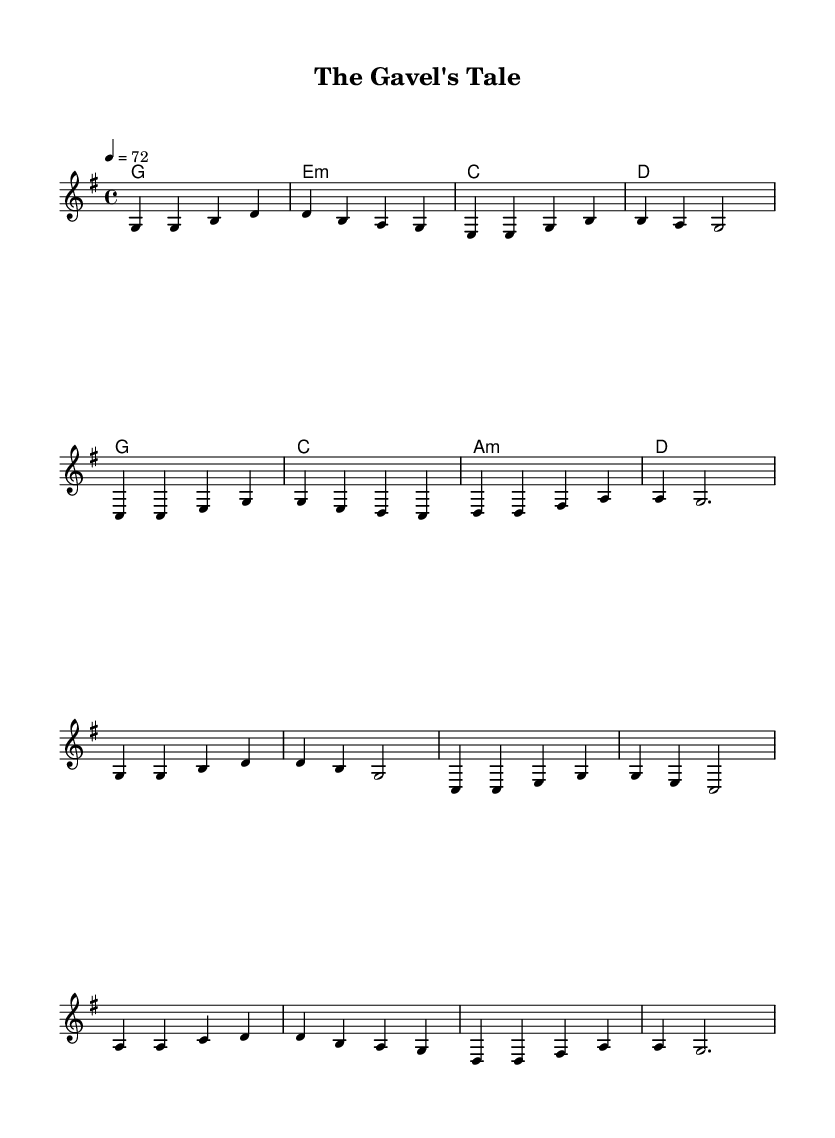What is the key signature of this music? The key signature is G major, which has one sharp (F#). This can be determined by looking at the key signature at the beginning of the staff.
Answer: G major What is the time signature of this music? The time signature is 4/4, which indicates there are four beats per measure and a quarter note gets one beat. This can be identified by the numbers located at the beginning of the score, indicating how many beats are in a measure and what note value gets the beat.
Answer: 4/4 What is the tempo marking in this music? The tempo marking is 72, indicating a moderate speed of 72 beats per minute. This is typically indicated at the beginning of the score in a numeric format following the tempo instruction.
Answer: 72 What is the first chord in the harmony section? The first chord is G major, which is confirmed by looking at the chord symbols written above the staff. The first symbol indicates the chord that will be played alongside the melody.
Answer: G How many measures are there in the verse section? There are eight measures in the verse section as seen by counting the number of groups of notes divided by vertical lines, which are called bar lines, in the melody section that are marked as the verse.
Answer: 8 Which chord follows the G major chord in the chorus? The chord that follows the G major chord is C major, as indicated by the second chord symbol in the chorus section of the harmony. Chord symbols are displayed above the melody, and the second one is C.
Answer: C How many notes are played in the second measure of the melody? There are four notes played in the second measure of the melody as counted by each note within the measure, which is defined by the bar lines. The notes in the second measure are: D, B, A, G.
Answer: 4 